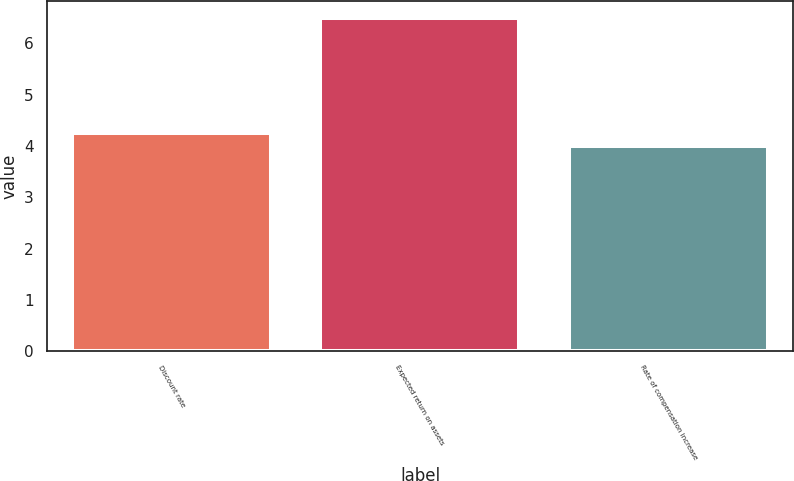<chart> <loc_0><loc_0><loc_500><loc_500><bar_chart><fcel>Discount rate<fcel>Expected return on assets<fcel>Rate of compensation increase<nl><fcel>4.25<fcel>6.5<fcel>4<nl></chart> 